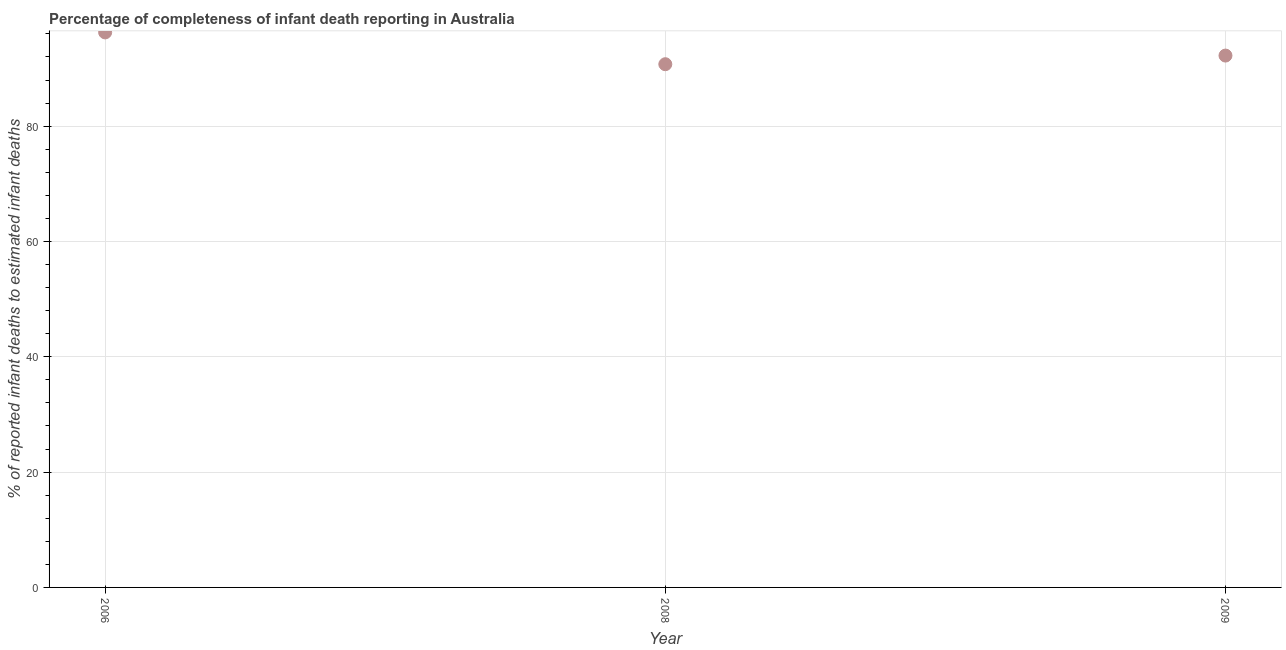What is the completeness of infant death reporting in 2006?
Offer a terse response. 96.26. Across all years, what is the maximum completeness of infant death reporting?
Provide a short and direct response. 96.26. Across all years, what is the minimum completeness of infant death reporting?
Keep it short and to the point. 90.75. What is the sum of the completeness of infant death reporting?
Offer a very short reply. 279.26. What is the difference between the completeness of infant death reporting in 2006 and 2008?
Offer a very short reply. 5.51. What is the average completeness of infant death reporting per year?
Give a very brief answer. 93.09. What is the median completeness of infant death reporting?
Ensure brevity in your answer.  92.25. What is the ratio of the completeness of infant death reporting in 2006 to that in 2008?
Make the answer very short. 1.06. Is the difference between the completeness of infant death reporting in 2006 and 2008 greater than the difference between any two years?
Your answer should be compact. Yes. What is the difference between the highest and the second highest completeness of infant death reporting?
Your answer should be compact. 4.02. Is the sum of the completeness of infant death reporting in 2006 and 2009 greater than the maximum completeness of infant death reporting across all years?
Provide a short and direct response. Yes. What is the difference between the highest and the lowest completeness of infant death reporting?
Ensure brevity in your answer.  5.51. In how many years, is the completeness of infant death reporting greater than the average completeness of infant death reporting taken over all years?
Your answer should be compact. 1. Does the completeness of infant death reporting monotonically increase over the years?
Provide a succinct answer. No. How many dotlines are there?
Provide a succinct answer. 1. How many years are there in the graph?
Provide a short and direct response. 3. What is the difference between two consecutive major ticks on the Y-axis?
Make the answer very short. 20. Are the values on the major ticks of Y-axis written in scientific E-notation?
Offer a terse response. No. Does the graph contain any zero values?
Keep it short and to the point. No. What is the title of the graph?
Provide a short and direct response. Percentage of completeness of infant death reporting in Australia. What is the label or title of the X-axis?
Offer a very short reply. Year. What is the label or title of the Y-axis?
Provide a succinct answer. % of reported infant deaths to estimated infant deaths. What is the % of reported infant deaths to estimated infant deaths in 2006?
Your answer should be compact. 96.26. What is the % of reported infant deaths to estimated infant deaths in 2008?
Keep it short and to the point. 90.75. What is the % of reported infant deaths to estimated infant deaths in 2009?
Provide a succinct answer. 92.25. What is the difference between the % of reported infant deaths to estimated infant deaths in 2006 and 2008?
Provide a short and direct response. 5.51. What is the difference between the % of reported infant deaths to estimated infant deaths in 2006 and 2009?
Offer a very short reply. 4.02. What is the difference between the % of reported infant deaths to estimated infant deaths in 2008 and 2009?
Keep it short and to the point. -1.5. What is the ratio of the % of reported infant deaths to estimated infant deaths in 2006 to that in 2008?
Keep it short and to the point. 1.06. What is the ratio of the % of reported infant deaths to estimated infant deaths in 2006 to that in 2009?
Make the answer very short. 1.04. What is the ratio of the % of reported infant deaths to estimated infant deaths in 2008 to that in 2009?
Keep it short and to the point. 0.98. 